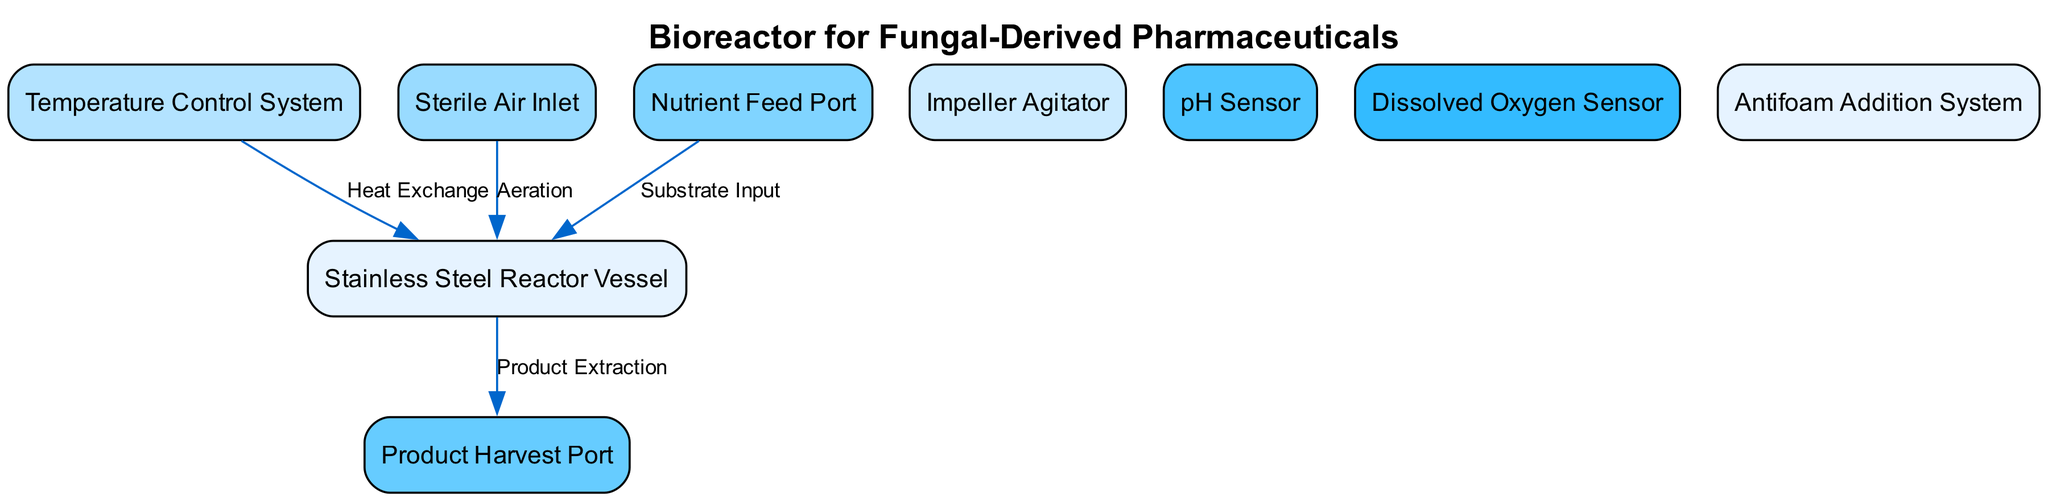What is the primary material of the reactor vessel? The diagram identifies the reactor vessel by the label "Stainless Steel Reactor Vessel." Thus, the primary material is stainless steel.
Answer: stainless steel How many main components are displayed in the diagram? By counting the nodes listed in the diagram, there are 9 distinct components representing different parts of the bioreactor.
Answer: 9 What is the function of the sterile air inlet? The diagram features an edge labeled "Aeration" that connects the "Sterile Air Inlet" to the "Stainless Steel Reactor Vessel," indicating that its function is to provide aeration to the reactor.
Answer: aeration What type of system is used for temperature regulation in the bioreactor? The diagram includes a node labeled "Temperature Control System," indicating that this system regulates the temperature within the reactor.
Answer: Temperature Control System Which node is directly connected to the product harvest port? The edge from the "Stainless Steel Reactor Vessel" labeled "Product Extraction" indicates that this component is directly connected to the "Product Harvest Port."
Answer: Stainless Steel Reactor Vessel What is the purpose of the nutrient feed port? The edge labeled "Substrate Input" connects the "Nutrient Feed Port" to the "Stainless Steel Reactor Vessel," indicating that the nutrient feed port is used to deliver substrates into the reactor for fungal growth.
Answer: substrate input How does the antifoam addition occur in the bioreactor? While the diagram does not directly show the connection of the "Antifoam Addition System" to other components, it can be inferred that it serves to control foam levels, which is essential during fermentation processes.
Answer: control foam levels What sensors are present in the bioreactor for monitoring its conditions? The diagram presents two sensors: "pH Sensor" and "Dissolved Oxygen Sensor." These sensors are critical for monitoring the growth conditions of the fungi.
Answer: pH Sensor, Dissolved Oxygen Sensor Which component manages the heat exchange in the reactor? The node labeled "Temperature Control System" is linked to the "Stainless Steel Reactor Vessel" through an edge marked "Heat Exchange," indicating that it manages the heat exchange.
Answer: Temperature Control System 